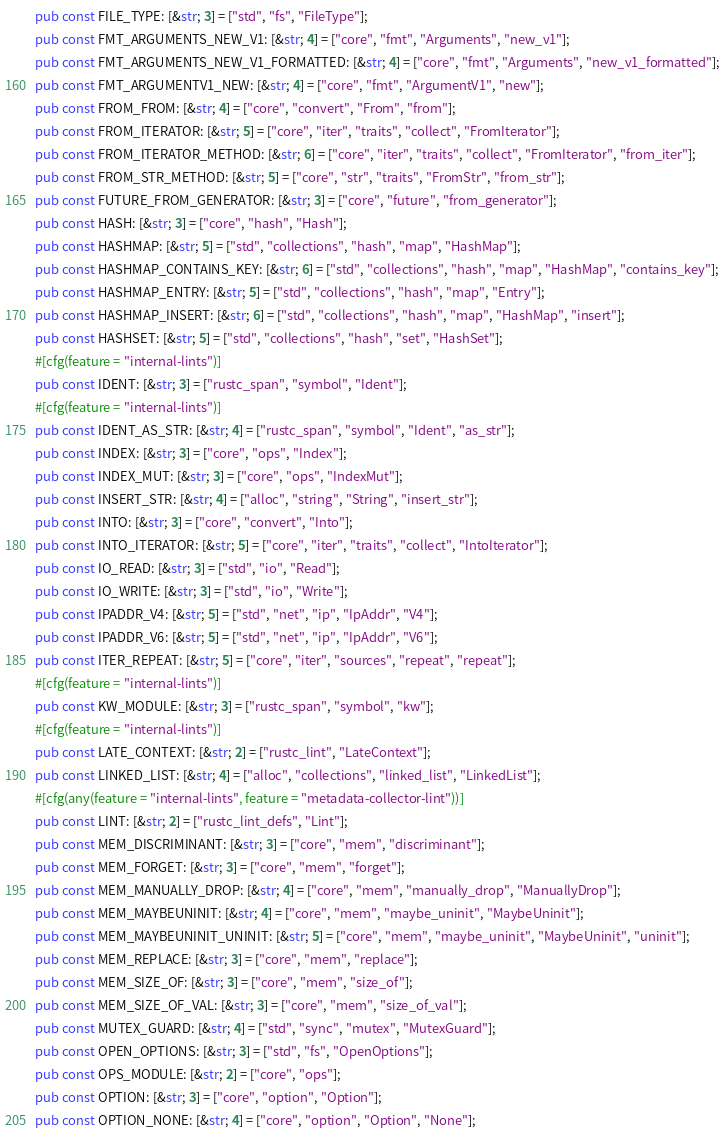Convert code to text. <code><loc_0><loc_0><loc_500><loc_500><_Rust_>pub const FILE_TYPE: [&str; 3] = ["std", "fs", "FileType"];
pub const FMT_ARGUMENTS_NEW_V1: [&str; 4] = ["core", "fmt", "Arguments", "new_v1"];
pub const FMT_ARGUMENTS_NEW_V1_FORMATTED: [&str; 4] = ["core", "fmt", "Arguments", "new_v1_formatted"];
pub const FMT_ARGUMENTV1_NEW: [&str; 4] = ["core", "fmt", "ArgumentV1", "new"];
pub const FROM_FROM: [&str; 4] = ["core", "convert", "From", "from"];
pub const FROM_ITERATOR: [&str; 5] = ["core", "iter", "traits", "collect", "FromIterator"];
pub const FROM_ITERATOR_METHOD: [&str; 6] = ["core", "iter", "traits", "collect", "FromIterator", "from_iter"];
pub const FROM_STR_METHOD: [&str; 5] = ["core", "str", "traits", "FromStr", "from_str"];
pub const FUTURE_FROM_GENERATOR: [&str; 3] = ["core", "future", "from_generator"];
pub const HASH: [&str; 3] = ["core", "hash", "Hash"];
pub const HASHMAP: [&str; 5] = ["std", "collections", "hash", "map", "HashMap"];
pub const HASHMAP_CONTAINS_KEY: [&str; 6] = ["std", "collections", "hash", "map", "HashMap", "contains_key"];
pub const HASHMAP_ENTRY: [&str; 5] = ["std", "collections", "hash", "map", "Entry"];
pub const HASHMAP_INSERT: [&str; 6] = ["std", "collections", "hash", "map", "HashMap", "insert"];
pub const HASHSET: [&str; 5] = ["std", "collections", "hash", "set", "HashSet"];
#[cfg(feature = "internal-lints")]
pub const IDENT: [&str; 3] = ["rustc_span", "symbol", "Ident"];
#[cfg(feature = "internal-lints")]
pub const IDENT_AS_STR: [&str; 4] = ["rustc_span", "symbol", "Ident", "as_str"];
pub const INDEX: [&str; 3] = ["core", "ops", "Index"];
pub const INDEX_MUT: [&str; 3] = ["core", "ops", "IndexMut"];
pub const INSERT_STR: [&str; 4] = ["alloc", "string", "String", "insert_str"];
pub const INTO: [&str; 3] = ["core", "convert", "Into"];
pub const INTO_ITERATOR: [&str; 5] = ["core", "iter", "traits", "collect", "IntoIterator"];
pub const IO_READ: [&str; 3] = ["std", "io", "Read"];
pub const IO_WRITE: [&str; 3] = ["std", "io", "Write"];
pub const IPADDR_V4: [&str; 5] = ["std", "net", "ip", "IpAddr", "V4"];
pub const IPADDR_V6: [&str; 5] = ["std", "net", "ip", "IpAddr", "V6"];
pub const ITER_REPEAT: [&str; 5] = ["core", "iter", "sources", "repeat", "repeat"];
#[cfg(feature = "internal-lints")]
pub const KW_MODULE: [&str; 3] = ["rustc_span", "symbol", "kw"];
#[cfg(feature = "internal-lints")]
pub const LATE_CONTEXT: [&str; 2] = ["rustc_lint", "LateContext"];
pub const LINKED_LIST: [&str; 4] = ["alloc", "collections", "linked_list", "LinkedList"];
#[cfg(any(feature = "internal-lints", feature = "metadata-collector-lint"))]
pub const LINT: [&str; 2] = ["rustc_lint_defs", "Lint"];
pub const MEM_DISCRIMINANT: [&str; 3] = ["core", "mem", "discriminant"];
pub const MEM_FORGET: [&str; 3] = ["core", "mem", "forget"];
pub const MEM_MANUALLY_DROP: [&str; 4] = ["core", "mem", "manually_drop", "ManuallyDrop"];
pub const MEM_MAYBEUNINIT: [&str; 4] = ["core", "mem", "maybe_uninit", "MaybeUninit"];
pub const MEM_MAYBEUNINIT_UNINIT: [&str; 5] = ["core", "mem", "maybe_uninit", "MaybeUninit", "uninit"];
pub const MEM_REPLACE: [&str; 3] = ["core", "mem", "replace"];
pub const MEM_SIZE_OF: [&str; 3] = ["core", "mem", "size_of"];
pub const MEM_SIZE_OF_VAL: [&str; 3] = ["core", "mem", "size_of_val"];
pub const MUTEX_GUARD: [&str; 4] = ["std", "sync", "mutex", "MutexGuard"];
pub const OPEN_OPTIONS: [&str; 3] = ["std", "fs", "OpenOptions"];
pub const OPS_MODULE: [&str; 2] = ["core", "ops"];
pub const OPTION: [&str; 3] = ["core", "option", "Option"];
pub const OPTION_NONE: [&str; 4] = ["core", "option", "Option", "None"];</code> 